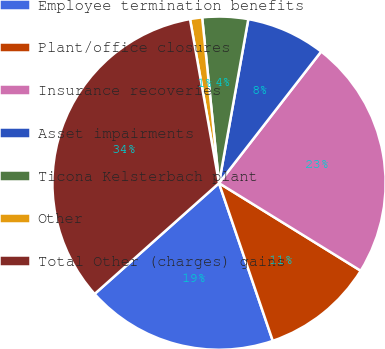Convert chart to OTSL. <chart><loc_0><loc_0><loc_500><loc_500><pie_chart><fcel>Employee termination benefits<fcel>Plant/office closures<fcel>Insurance recoveries<fcel>Asset impairments<fcel>Ticona Kelsterbach plant<fcel>Other<fcel>Total Other (charges) gains<nl><fcel>18.65%<fcel>10.96%<fcel>23.31%<fcel>7.69%<fcel>4.43%<fcel>1.17%<fcel>33.8%<nl></chart> 